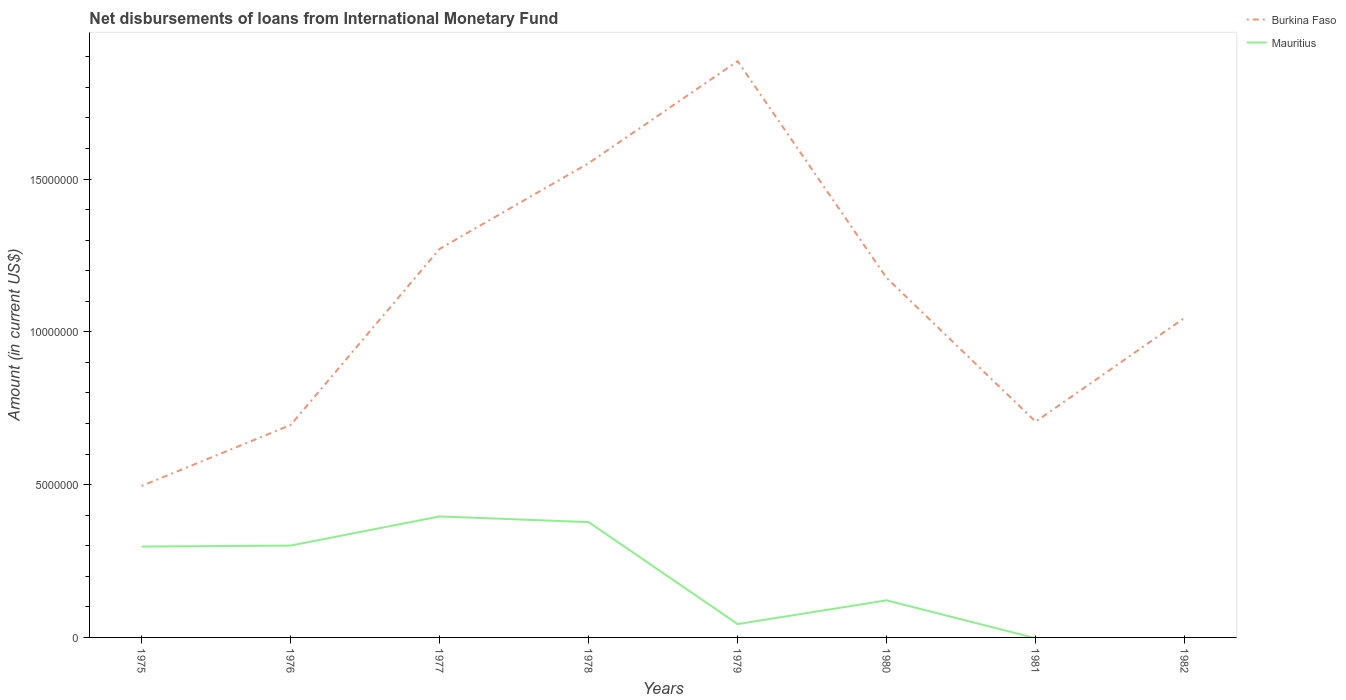How many different coloured lines are there?
Your answer should be very brief. 2. Across all years, what is the maximum amount of loans disbursed in Burkina Faso?
Keep it short and to the point. 4.96e+06. What is the total amount of loans disbursed in Burkina Faso in the graph?
Provide a short and direct response. 4.70e+06. What is the difference between the highest and the second highest amount of loans disbursed in Mauritius?
Your answer should be compact. 3.96e+06. What is the difference between the highest and the lowest amount of loans disbursed in Mauritius?
Your response must be concise. 4. Is the amount of loans disbursed in Mauritius strictly greater than the amount of loans disbursed in Burkina Faso over the years?
Ensure brevity in your answer.  Yes. How many lines are there?
Offer a very short reply. 2. How many years are there in the graph?
Ensure brevity in your answer.  8. Does the graph contain any zero values?
Your answer should be compact. Yes. Where does the legend appear in the graph?
Your response must be concise. Top right. What is the title of the graph?
Your answer should be very brief. Net disbursements of loans from International Monetary Fund. Does "Mongolia" appear as one of the legend labels in the graph?
Provide a short and direct response. No. What is the Amount (in current US$) in Burkina Faso in 1975?
Ensure brevity in your answer.  4.96e+06. What is the Amount (in current US$) of Mauritius in 1975?
Provide a succinct answer. 2.97e+06. What is the Amount (in current US$) of Burkina Faso in 1976?
Your answer should be very brief. 6.95e+06. What is the Amount (in current US$) of Mauritius in 1976?
Keep it short and to the point. 3.01e+06. What is the Amount (in current US$) of Burkina Faso in 1977?
Make the answer very short. 1.27e+07. What is the Amount (in current US$) in Mauritius in 1977?
Offer a terse response. 3.96e+06. What is the Amount (in current US$) of Burkina Faso in 1978?
Your answer should be very brief. 1.55e+07. What is the Amount (in current US$) in Mauritius in 1978?
Make the answer very short. 3.77e+06. What is the Amount (in current US$) of Burkina Faso in 1979?
Offer a very short reply. 1.89e+07. What is the Amount (in current US$) in Mauritius in 1979?
Offer a very short reply. 4.37e+05. What is the Amount (in current US$) of Burkina Faso in 1980?
Ensure brevity in your answer.  1.18e+07. What is the Amount (in current US$) of Mauritius in 1980?
Give a very brief answer. 1.21e+06. What is the Amount (in current US$) of Burkina Faso in 1981?
Keep it short and to the point. 7.06e+06. What is the Amount (in current US$) in Burkina Faso in 1982?
Your response must be concise. 1.05e+07. What is the Amount (in current US$) in Mauritius in 1982?
Provide a succinct answer. 0. Across all years, what is the maximum Amount (in current US$) of Burkina Faso?
Your answer should be compact. 1.89e+07. Across all years, what is the maximum Amount (in current US$) in Mauritius?
Keep it short and to the point. 3.96e+06. Across all years, what is the minimum Amount (in current US$) in Burkina Faso?
Your answer should be very brief. 4.96e+06. Across all years, what is the minimum Amount (in current US$) of Mauritius?
Give a very brief answer. 0. What is the total Amount (in current US$) of Burkina Faso in the graph?
Make the answer very short. 8.83e+07. What is the total Amount (in current US$) in Mauritius in the graph?
Give a very brief answer. 1.54e+07. What is the difference between the Amount (in current US$) of Burkina Faso in 1975 and that in 1976?
Your response must be concise. -2.00e+06. What is the difference between the Amount (in current US$) in Mauritius in 1975 and that in 1976?
Provide a short and direct response. -3.30e+04. What is the difference between the Amount (in current US$) of Burkina Faso in 1975 and that in 1977?
Provide a succinct answer. -7.76e+06. What is the difference between the Amount (in current US$) in Mauritius in 1975 and that in 1977?
Ensure brevity in your answer.  -9.86e+05. What is the difference between the Amount (in current US$) of Burkina Faso in 1975 and that in 1978?
Your response must be concise. -1.06e+07. What is the difference between the Amount (in current US$) in Mauritius in 1975 and that in 1978?
Provide a succinct answer. -8.01e+05. What is the difference between the Amount (in current US$) of Burkina Faso in 1975 and that in 1979?
Your response must be concise. -1.39e+07. What is the difference between the Amount (in current US$) in Mauritius in 1975 and that in 1979?
Offer a very short reply. 2.54e+06. What is the difference between the Amount (in current US$) of Burkina Faso in 1975 and that in 1980?
Your answer should be compact. -6.81e+06. What is the difference between the Amount (in current US$) in Mauritius in 1975 and that in 1980?
Make the answer very short. 1.76e+06. What is the difference between the Amount (in current US$) in Burkina Faso in 1975 and that in 1981?
Offer a terse response. -2.10e+06. What is the difference between the Amount (in current US$) in Burkina Faso in 1975 and that in 1982?
Ensure brevity in your answer.  -5.50e+06. What is the difference between the Amount (in current US$) of Burkina Faso in 1976 and that in 1977?
Your answer should be compact. -5.76e+06. What is the difference between the Amount (in current US$) in Mauritius in 1976 and that in 1977?
Offer a terse response. -9.53e+05. What is the difference between the Amount (in current US$) in Burkina Faso in 1976 and that in 1978?
Provide a short and direct response. -8.57e+06. What is the difference between the Amount (in current US$) of Mauritius in 1976 and that in 1978?
Make the answer very short. -7.68e+05. What is the difference between the Amount (in current US$) in Burkina Faso in 1976 and that in 1979?
Your response must be concise. -1.19e+07. What is the difference between the Amount (in current US$) in Mauritius in 1976 and that in 1979?
Ensure brevity in your answer.  2.57e+06. What is the difference between the Amount (in current US$) in Burkina Faso in 1976 and that in 1980?
Offer a terse response. -4.81e+06. What is the difference between the Amount (in current US$) in Mauritius in 1976 and that in 1980?
Keep it short and to the point. 1.79e+06. What is the difference between the Amount (in current US$) in Burkina Faso in 1976 and that in 1981?
Provide a succinct answer. -1.09e+05. What is the difference between the Amount (in current US$) in Burkina Faso in 1976 and that in 1982?
Offer a very short reply. -3.51e+06. What is the difference between the Amount (in current US$) in Burkina Faso in 1977 and that in 1978?
Provide a short and direct response. -2.80e+06. What is the difference between the Amount (in current US$) in Mauritius in 1977 and that in 1978?
Ensure brevity in your answer.  1.85e+05. What is the difference between the Amount (in current US$) in Burkina Faso in 1977 and that in 1979?
Keep it short and to the point. -6.14e+06. What is the difference between the Amount (in current US$) of Mauritius in 1977 and that in 1979?
Offer a terse response. 3.52e+06. What is the difference between the Amount (in current US$) in Burkina Faso in 1977 and that in 1980?
Your answer should be very brief. 9.51e+05. What is the difference between the Amount (in current US$) in Mauritius in 1977 and that in 1980?
Give a very brief answer. 2.75e+06. What is the difference between the Amount (in current US$) in Burkina Faso in 1977 and that in 1981?
Offer a very short reply. 5.66e+06. What is the difference between the Amount (in current US$) of Burkina Faso in 1977 and that in 1982?
Keep it short and to the point. 2.26e+06. What is the difference between the Amount (in current US$) of Burkina Faso in 1978 and that in 1979?
Keep it short and to the point. -3.34e+06. What is the difference between the Amount (in current US$) of Mauritius in 1978 and that in 1979?
Keep it short and to the point. 3.34e+06. What is the difference between the Amount (in current US$) in Burkina Faso in 1978 and that in 1980?
Your answer should be very brief. 3.76e+06. What is the difference between the Amount (in current US$) in Mauritius in 1978 and that in 1980?
Offer a terse response. 2.56e+06. What is the difference between the Amount (in current US$) of Burkina Faso in 1978 and that in 1981?
Your response must be concise. 8.46e+06. What is the difference between the Amount (in current US$) in Burkina Faso in 1978 and that in 1982?
Make the answer very short. 5.06e+06. What is the difference between the Amount (in current US$) of Burkina Faso in 1979 and that in 1980?
Offer a very short reply. 7.09e+06. What is the difference between the Amount (in current US$) in Mauritius in 1979 and that in 1980?
Give a very brief answer. -7.76e+05. What is the difference between the Amount (in current US$) of Burkina Faso in 1979 and that in 1981?
Give a very brief answer. 1.18e+07. What is the difference between the Amount (in current US$) in Burkina Faso in 1979 and that in 1982?
Keep it short and to the point. 8.40e+06. What is the difference between the Amount (in current US$) of Burkina Faso in 1980 and that in 1981?
Your answer should be compact. 4.70e+06. What is the difference between the Amount (in current US$) in Burkina Faso in 1980 and that in 1982?
Ensure brevity in your answer.  1.30e+06. What is the difference between the Amount (in current US$) of Burkina Faso in 1981 and that in 1982?
Provide a succinct answer. -3.40e+06. What is the difference between the Amount (in current US$) in Burkina Faso in 1975 and the Amount (in current US$) in Mauritius in 1976?
Keep it short and to the point. 1.95e+06. What is the difference between the Amount (in current US$) in Burkina Faso in 1975 and the Amount (in current US$) in Mauritius in 1977?
Your answer should be very brief. 9.98e+05. What is the difference between the Amount (in current US$) of Burkina Faso in 1975 and the Amount (in current US$) of Mauritius in 1978?
Make the answer very short. 1.18e+06. What is the difference between the Amount (in current US$) in Burkina Faso in 1975 and the Amount (in current US$) in Mauritius in 1979?
Your answer should be very brief. 4.52e+06. What is the difference between the Amount (in current US$) of Burkina Faso in 1975 and the Amount (in current US$) of Mauritius in 1980?
Ensure brevity in your answer.  3.74e+06. What is the difference between the Amount (in current US$) in Burkina Faso in 1976 and the Amount (in current US$) in Mauritius in 1977?
Your answer should be very brief. 2.99e+06. What is the difference between the Amount (in current US$) in Burkina Faso in 1976 and the Amount (in current US$) in Mauritius in 1978?
Offer a very short reply. 3.18e+06. What is the difference between the Amount (in current US$) of Burkina Faso in 1976 and the Amount (in current US$) of Mauritius in 1979?
Provide a succinct answer. 6.52e+06. What is the difference between the Amount (in current US$) in Burkina Faso in 1976 and the Amount (in current US$) in Mauritius in 1980?
Ensure brevity in your answer.  5.74e+06. What is the difference between the Amount (in current US$) of Burkina Faso in 1977 and the Amount (in current US$) of Mauritius in 1978?
Provide a succinct answer. 8.94e+06. What is the difference between the Amount (in current US$) of Burkina Faso in 1977 and the Amount (in current US$) of Mauritius in 1979?
Provide a succinct answer. 1.23e+07. What is the difference between the Amount (in current US$) of Burkina Faso in 1977 and the Amount (in current US$) of Mauritius in 1980?
Keep it short and to the point. 1.15e+07. What is the difference between the Amount (in current US$) of Burkina Faso in 1978 and the Amount (in current US$) of Mauritius in 1979?
Ensure brevity in your answer.  1.51e+07. What is the difference between the Amount (in current US$) in Burkina Faso in 1978 and the Amount (in current US$) in Mauritius in 1980?
Your response must be concise. 1.43e+07. What is the difference between the Amount (in current US$) in Burkina Faso in 1979 and the Amount (in current US$) in Mauritius in 1980?
Make the answer very short. 1.76e+07. What is the average Amount (in current US$) of Burkina Faso per year?
Keep it short and to the point. 1.10e+07. What is the average Amount (in current US$) in Mauritius per year?
Give a very brief answer. 1.92e+06. In the year 1975, what is the difference between the Amount (in current US$) of Burkina Faso and Amount (in current US$) of Mauritius?
Offer a terse response. 1.98e+06. In the year 1976, what is the difference between the Amount (in current US$) of Burkina Faso and Amount (in current US$) of Mauritius?
Keep it short and to the point. 3.95e+06. In the year 1977, what is the difference between the Amount (in current US$) of Burkina Faso and Amount (in current US$) of Mauritius?
Provide a succinct answer. 8.76e+06. In the year 1978, what is the difference between the Amount (in current US$) of Burkina Faso and Amount (in current US$) of Mauritius?
Give a very brief answer. 1.17e+07. In the year 1979, what is the difference between the Amount (in current US$) of Burkina Faso and Amount (in current US$) of Mauritius?
Offer a terse response. 1.84e+07. In the year 1980, what is the difference between the Amount (in current US$) in Burkina Faso and Amount (in current US$) in Mauritius?
Your answer should be very brief. 1.06e+07. What is the ratio of the Amount (in current US$) in Burkina Faso in 1975 to that in 1976?
Provide a short and direct response. 0.71. What is the ratio of the Amount (in current US$) of Burkina Faso in 1975 to that in 1977?
Provide a short and direct response. 0.39. What is the ratio of the Amount (in current US$) of Mauritius in 1975 to that in 1977?
Provide a succinct answer. 0.75. What is the ratio of the Amount (in current US$) in Burkina Faso in 1975 to that in 1978?
Keep it short and to the point. 0.32. What is the ratio of the Amount (in current US$) in Mauritius in 1975 to that in 1978?
Keep it short and to the point. 0.79. What is the ratio of the Amount (in current US$) in Burkina Faso in 1975 to that in 1979?
Make the answer very short. 0.26. What is the ratio of the Amount (in current US$) of Mauritius in 1975 to that in 1979?
Keep it short and to the point. 6.8. What is the ratio of the Amount (in current US$) in Burkina Faso in 1975 to that in 1980?
Your response must be concise. 0.42. What is the ratio of the Amount (in current US$) in Mauritius in 1975 to that in 1980?
Your answer should be very brief. 2.45. What is the ratio of the Amount (in current US$) of Burkina Faso in 1975 to that in 1981?
Your answer should be compact. 0.7. What is the ratio of the Amount (in current US$) of Burkina Faso in 1975 to that in 1982?
Your response must be concise. 0.47. What is the ratio of the Amount (in current US$) in Burkina Faso in 1976 to that in 1977?
Your answer should be very brief. 0.55. What is the ratio of the Amount (in current US$) in Mauritius in 1976 to that in 1977?
Offer a terse response. 0.76. What is the ratio of the Amount (in current US$) in Burkina Faso in 1976 to that in 1978?
Ensure brevity in your answer.  0.45. What is the ratio of the Amount (in current US$) in Mauritius in 1976 to that in 1978?
Make the answer very short. 0.8. What is the ratio of the Amount (in current US$) of Burkina Faso in 1976 to that in 1979?
Keep it short and to the point. 0.37. What is the ratio of the Amount (in current US$) in Mauritius in 1976 to that in 1979?
Your answer should be compact. 6.88. What is the ratio of the Amount (in current US$) of Burkina Faso in 1976 to that in 1980?
Offer a terse response. 0.59. What is the ratio of the Amount (in current US$) in Mauritius in 1976 to that in 1980?
Offer a very short reply. 2.48. What is the ratio of the Amount (in current US$) in Burkina Faso in 1976 to that in 1981?
Your answer should be very brief. 0.98. What is the ratio of the Amount (in current US$) in Burkina Faso in 1976 to that in 1982?
Offer a very short reply. 0.66. What is the ratio of the Amount (in current US$) of Burkina Faso in 1977 to that in 1978?
Offer a very short reply. 0.82. What is the ratio of the Amount (in current US$) in Mauritius in 1977 to that in 1978?
Your answer should be compact. 1.05. What is the ratio of the Amount (in current US$) of Burkina Faso in 1977 to that in 1979?
Give a very brief answer. 0.67. What is the ratio of the Amount (in current US$) in Mauritius in 1977 to that in 1979?
Your answer should be compact. 9.06. What is the ratio of the Amount (in current US$) in Burkina Faso in 1977 to that in 1980?
Offer a terse response. 1.08. What is the ratio of the Amount (in current US$) of Mauritius in 1977 to that in 1980?
Make the answer very short. 3.26. What is the ratio of the Amount (in current US$) in Burkina Faso in 1977 to that in 1981?
Make the answer very short. 1.8. What is the ratio of the Amount (in current US$) of Burkina Faso in 1977 to that in 1982?
Keep it short and to the point. 1.22. What is the ratio of the Amount (in current US$) in Burkina Faso in 1978 to that in 1979?
Offer a terse response. 0.82. What is the ratio of the Amount (in current US$) of Mauritius in 1978 to that in 1979?
Provide a succinct answer. 8.64. What is the ratio of the Amount (in current US$) of Burkina Faso in 1978 to that in 1980?
Your response must be concise. 1.32. What is the ratio of the Amount (in current US$) in Mauritius in 1978 to that in 1980?
Offer a very short reply. 3.11. What is the ratio of the Amount (in current US$) in Burkina Faso in 1978 to that in 1981?
Give a very brief answer. 2.2. What is the ratio of the Amount (in current US$) in Burkina Faso in 1978 to that in 1982?
Ensure brevity in your answer.  1.48. What is the ratio of the Amount (in current US$) in Burkina Faso in 1979 to that in 1980?
Give a very brief answer. 1.6. What is the ratio of the Amount (in current US$) of Mauritius in 1979 to that in 1980?
Provide a short and direct response. 0.36. What is the ratio of the Amount (in current US$) of Burkina Faso in 1979 to that in 1981?
Your answer should be very brief. 2.67. What is the ratio of the Amount (in current US$) in Burkina Faso in 1979 to that in 1982?
Give a very brief answer. 1.8. What is the ratio of the Amount (in current US$) in Burkina Faso in 1980 to that in 1981?
Provide a succinct answer. 1.67. What is the ratio of the Amount (in current US$) of Burkina Faso in 1980 to that in 1982?
Provide a succinct answer. 1.12. What is the ratio of the Amount (in current US$) of Burkina Faso in 1981 to that in 1982?
Your answer should be very brief. 0.68. What is the difference between the highest and the second highest Amount (in current US$) of Burkina Faso?
Ensure brevity in your answer.  3.34e+06. What is the difference between the highest and the second highest Amount (in current US$) in Mauritius?
Your answer should be very brief. 1.85e+05. What is the difference between the highest and the lowest Amount (in current US$) of Burkina Faso?
Your answer should be compact. 1.39e+07. What is the difference between the highest and the lowest Amount (in current US$) in Mauritius?
Offer a terse response. 3.96e+06. 